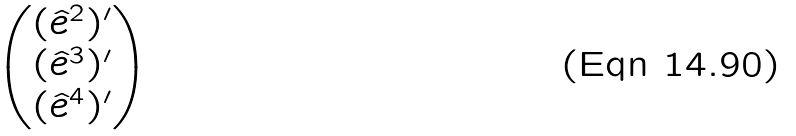Convert formula to latex. <formula><loc_0><loc_0><loc_500><loc_500>\begin{pmatrix} ( \hat { e } ^ { 2 } ) ^ { \prime } \\ ( \hat { e } ^ { 3 } ) ^ { \prime } \\ ( \hat { e } ^ { 4 } ) ^ { \prime } \end{pmatrix}</formula> 